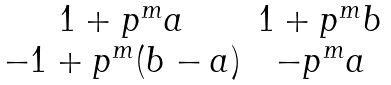Convert formula to latex. <formula><loc_0><loc_0><loc_500><loc_500>\begin{matrix} 1 + p ^ { m } a & 1 + p ^ { m } b \\ - 1 + p ^ { m } ( b - a ) & - p ^ { m } a \end{matrix}</formula> 